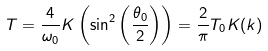<formula> <loc_0><loc_0><loc_500><loc_500>T = \frac { 4 } { \omega _ { 0 } } K \left ( \sin ^ { 2 } \left ( \frac { \theta _ { 0 } } { 2 } \right ) \right ) = \frac { 2 } { \pi } T _ { 0 } K ( k )</formula> 